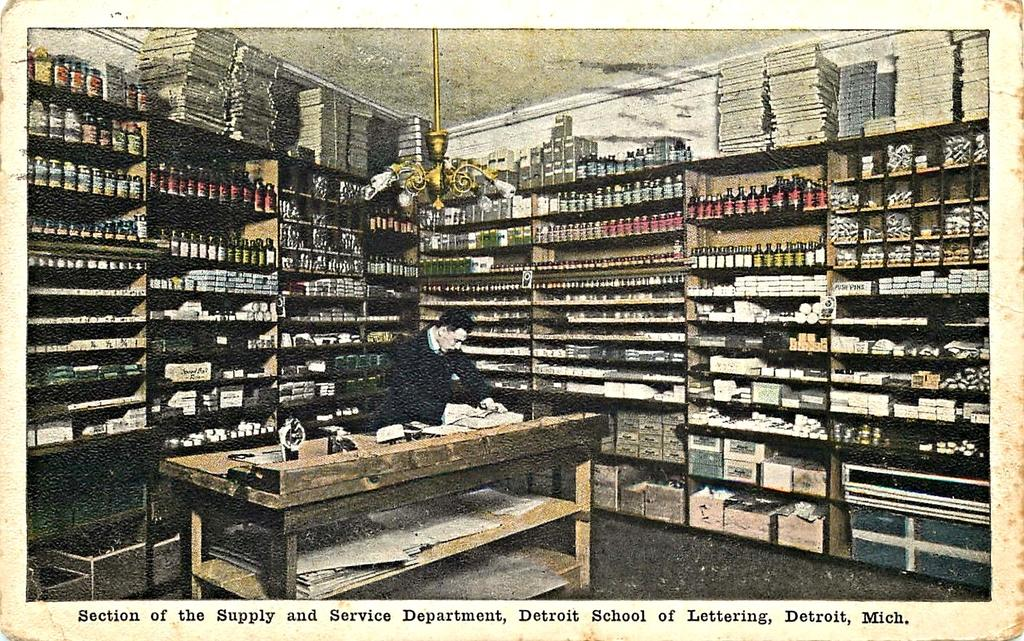<image>
Write a terse but informative summary of the picture. A postcard with a very distorted image of the section and service department of the School of Lettering in Detroit, Michigan. 